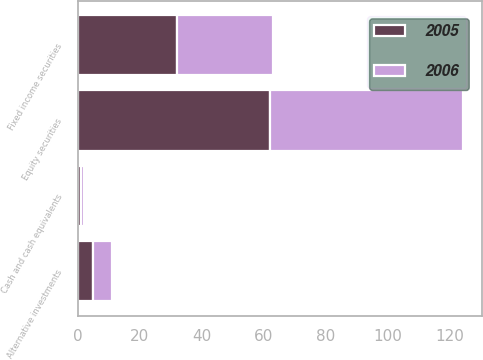Convert chart. <chart><loc_0><loc_0><loc_500><loc_500><stacked_bar_chart><ecel><fcel>Cash and cash equivalents<fcel>Equity securities<fcel>Fixed income securities<fcel>Alternative investments<nl><fcel>2006<fcel>1<fcel>62<fcel>31<fcel>6<nl><fcel>2005<fcel>1<fcel>62<fcel>32<fcel>5<nl></chart> 